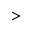<formula> <loc_0><loc_0><loc_500><loc_500>></formula> 